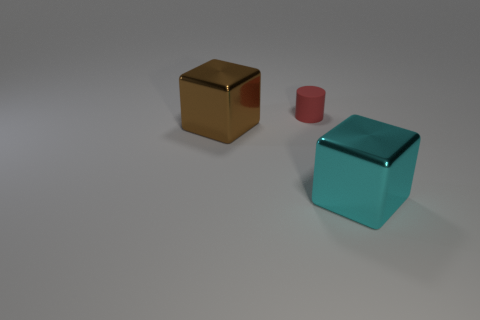Add 3 brown things. How many objects exist? 6 Subtract all cylinders. How many objects are left? 2 Subtract all brown cubes. How many brown cylinders are left? 0 Subtract all gray cylinders. Subtract all green balls. How many cylinders are left? 1 Subtract all large brown shiny cubes. Subtract all cyan metal blocks. How many objects are left? 1 Add 3 matte cylinders. How many matte cylinders are left? 4 Add 2 big red matte cylinders. How many big red matte cylinders exist? 2 Subtract 0 brown cylinders. How many objects are left? 3 